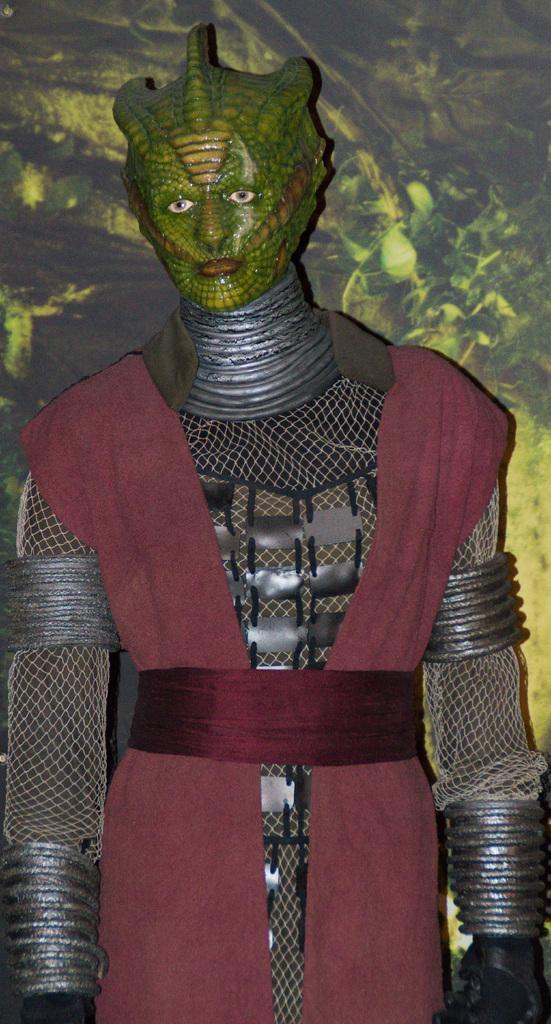Please provide a concise description of this image. In this image we can see a person wearing a costume. 